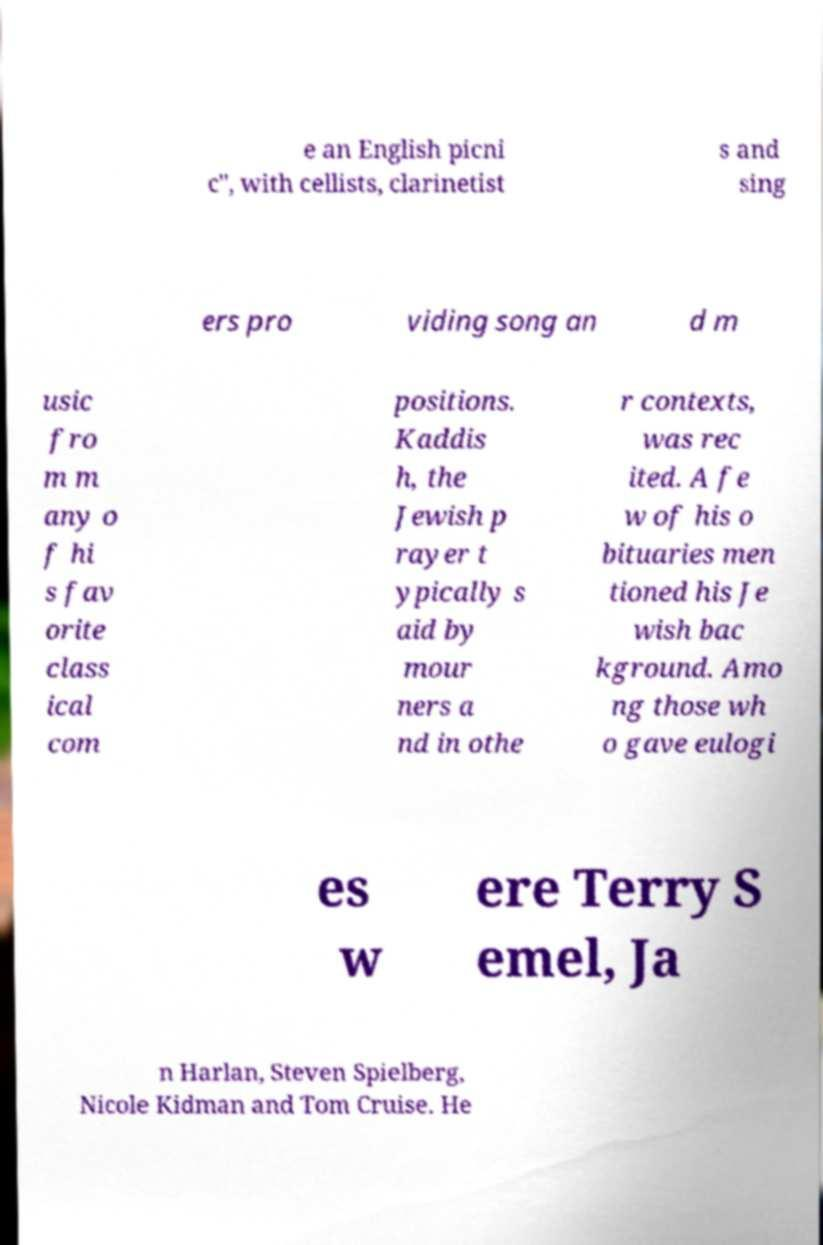Can you read and provide the text displayed in the image?This photo seems to have some interesting text. Can you extract and type it out for me? e an English picni c", with cellists, clarinetist s and sing ers pro viding song an d m usic fro m m any o f hi s fav orite class ical com positions. Kaddis h, the Jewish p rayer t ypically s aid by mour ners a nd in othe r contexts, was rec ited. A fe w of his o bituaries men tioned his Je wish bac kground. Amo ng those wh o gave eulogi es w ere Terry S emel, Ja n Harlan, Steven Spielberg, Nicole Kidman and Tom Cruise. He 